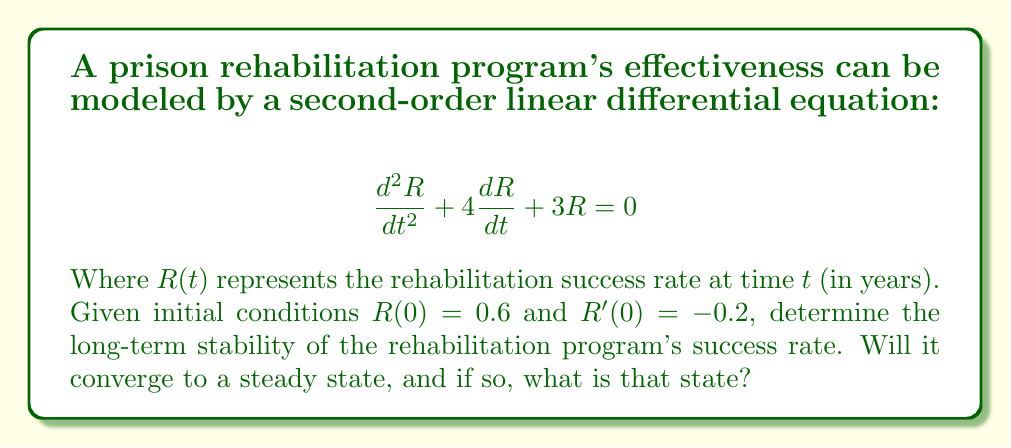Can you answer this question? To analyze the stability of this second-order system:

1) First, we need to find the characteristic equation:
   $$r^2 + 4r + 3 = 0$$

2) Solve for the roots:
   $$r = \frac{-4 \pm \sqrt{16 - 12}}{2} = \frac{-4 \pm \sqrt{4}}{2} = \frac{-4 \pm 2}{2}$$
   $$r_1 = -1, r_2 = -3$$

3) Since both roots are real and negative, the general solution is:
   $$R(t) = C_1e^{-t} + C_2e^{-3t}$$

4) To find $C_1$ and $C_2$, use the initial conditions:
   $R(0) = 0.6$: $C_1 + C_2 = 0.6$
   $R'(0) = -0.2$: $-C_1 - 3C_2 = -0.2$

5) Solving this system:
   $C_1 = 0.5$ and $C_2 = 0.1$

6) Therefore, the particular solution is:
   $$R(t) = 0.5e^{-t} + 0.1e^{-3t}$$

7) As $t \to \infty$, both $e^{-t}$ and $e^{-3t}$ approach 0.

Thus, the system is stable and converges to a steady state of 0.
Answer: The rehabilitation program's success rate converges to 0. 